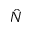Convert formula to latex. <formula><loc_0><loc_0><loc_500><loc_500>\hat { N }</formula> 